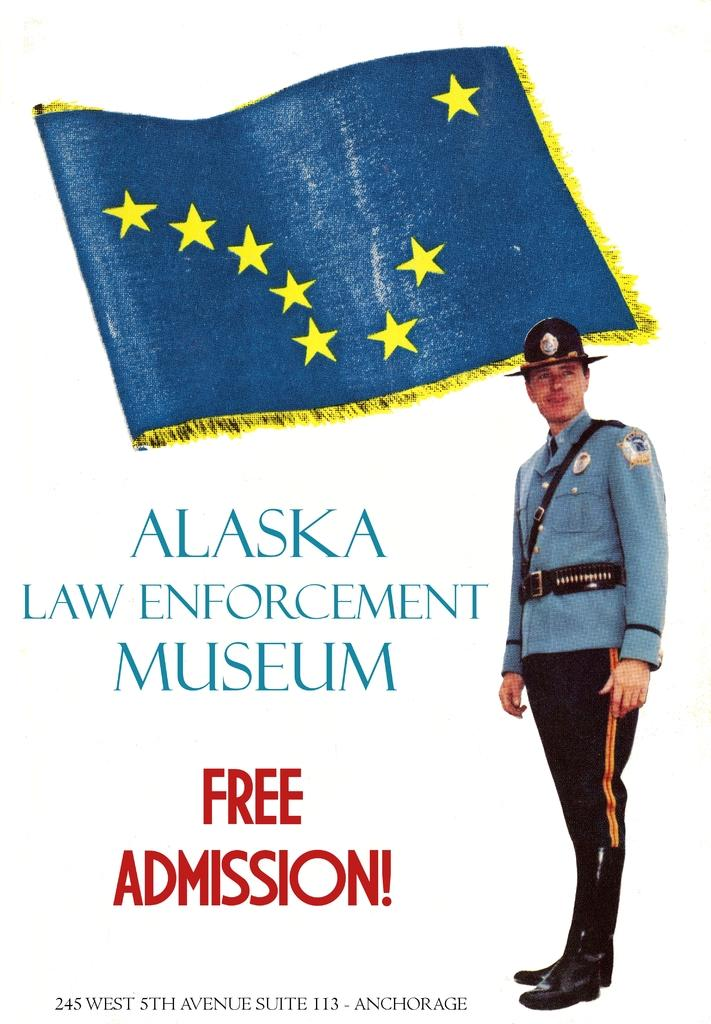What is featured in the image? There is a poster in the image. What is the main subject of the poster? The poster depicts a man standing. What is the man wearing on his head? The man is wearing a cap. What other elements are present in the poster? There is a flag and text on the poster. Can you see a window in the image? There is no window present in the image; it only features a poster. Is there a net visible in the image? There is no net present in the image. 